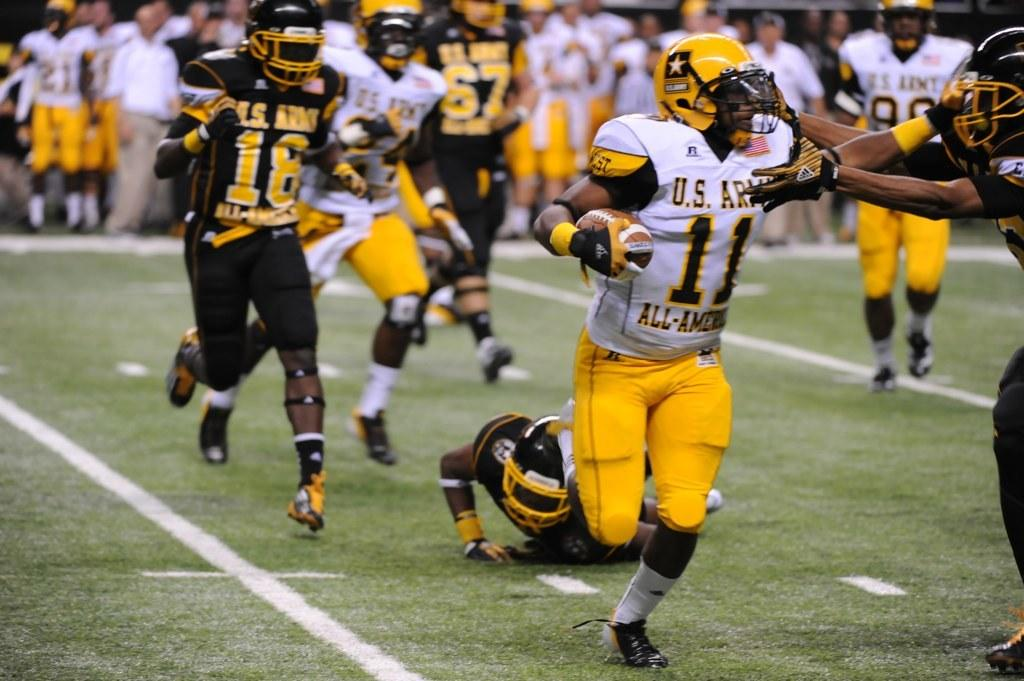What type of surface is at the bottom of the image? There is grass at the bottom of the image. What are the people in the image doing? The people in the image are running. Can you describe the background of the image? The background of the image is blurred. How many flies can be seen buzzing around the people in the image? There are no flies present in the image. What type of train is visible in the background of the image? There is no train visible in the image; the background is blurred. 